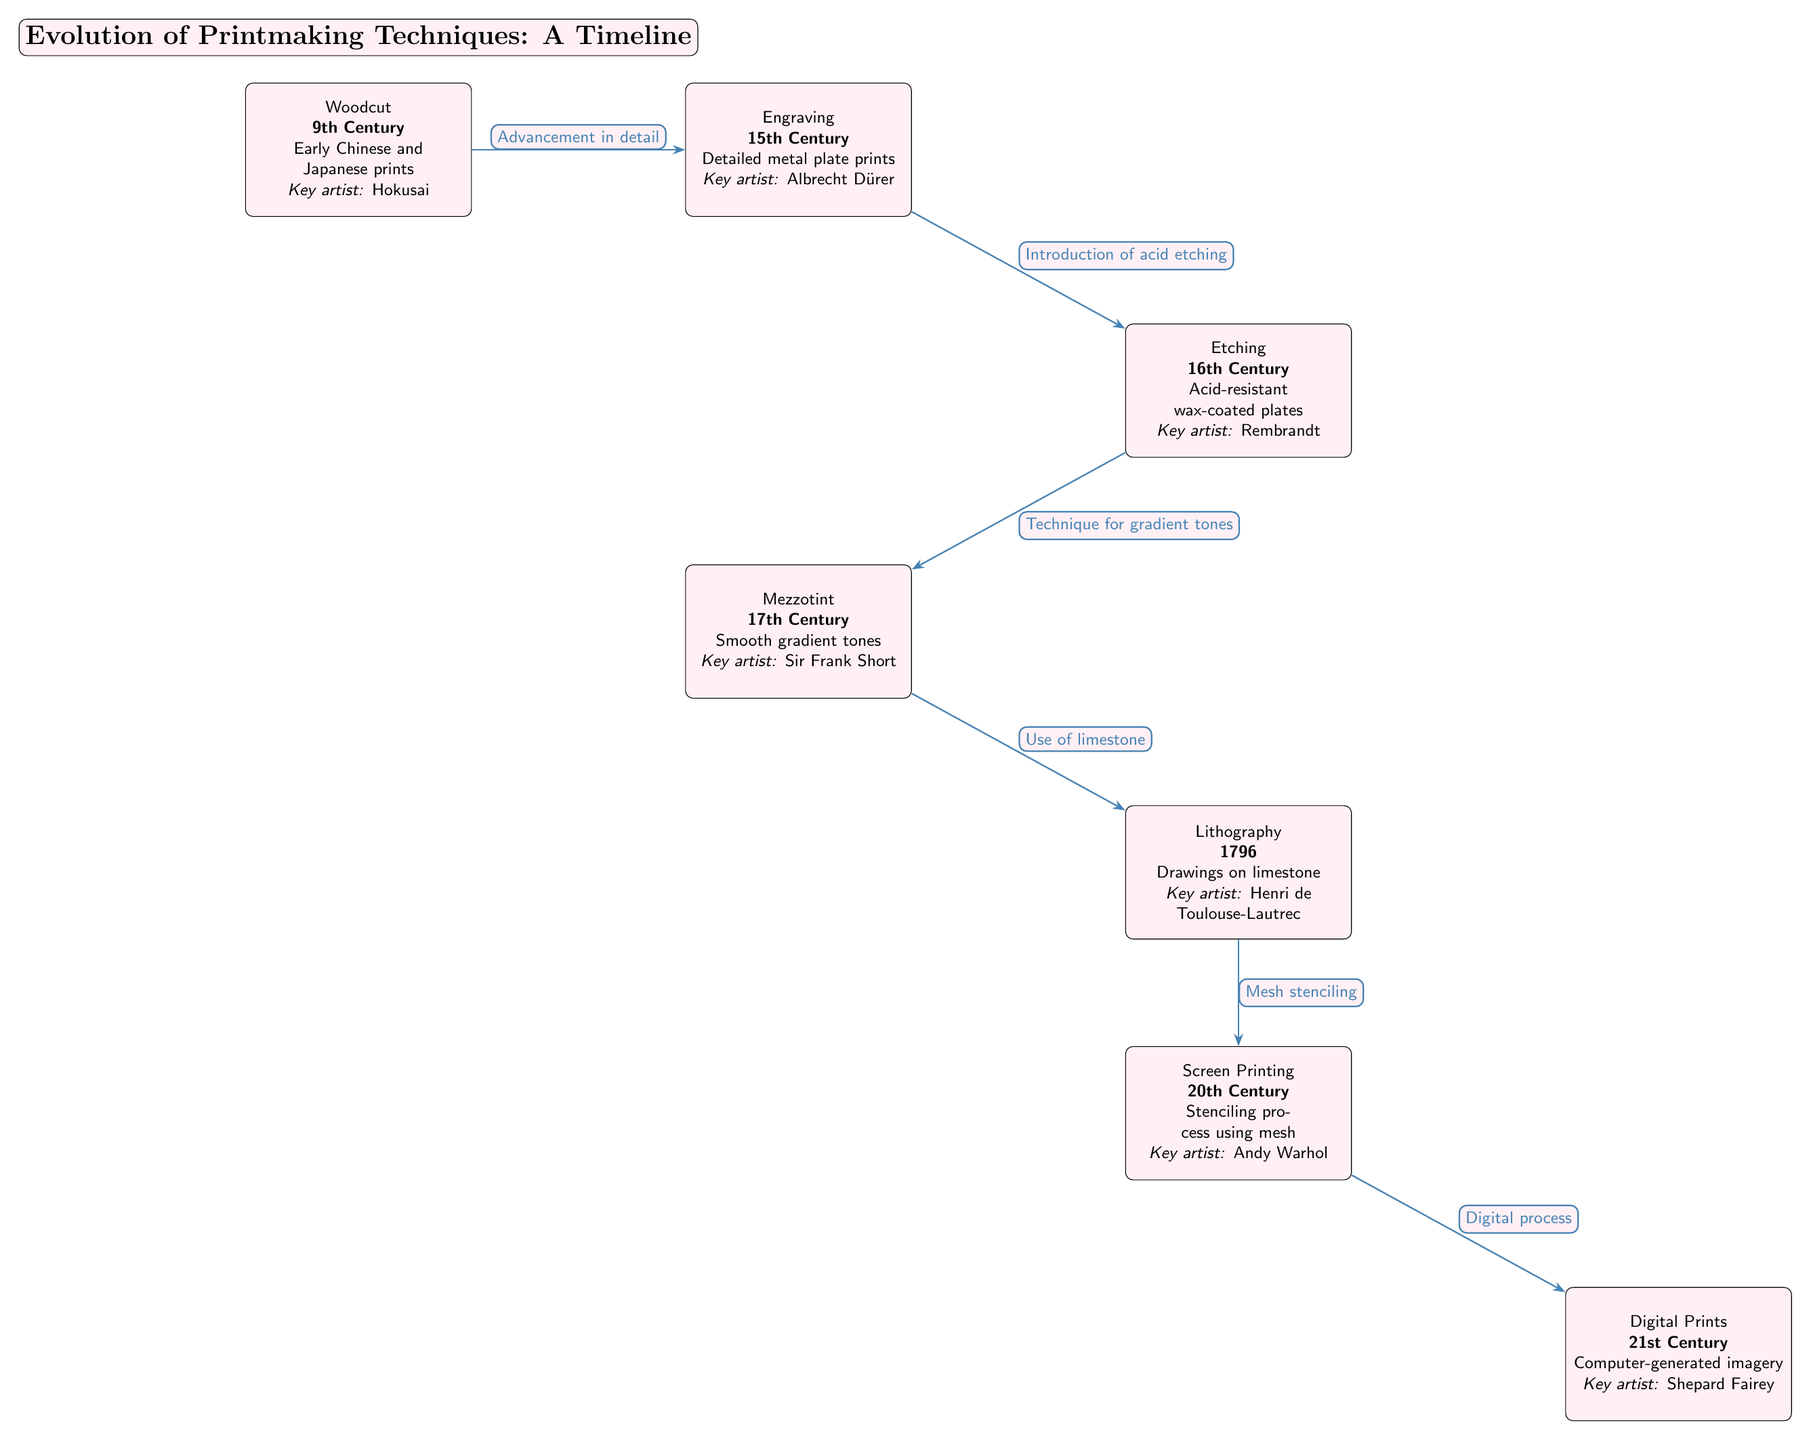What is the first technique in the timeline? The diagram lists "Woodcut" as the first technique, appearing at the top of the timeline under the 9th Century.
Answer: Woodcut Who is the key artist associated with engraving? According to the diagram, Albrecht Dürer is mentioned as the key artist associated with the engraving technique.
Answer: Albrecht Dürer What year did lithography emerge as a printmaking technique? The diagram specifies that lithography was introduced in the year 1796.
Answer: 1796 How many major printmaking techniques are shown in the diagram? Counting from Woodcut to Digital Prints, the diagram presents a total of six major printmaking techniques.
Answer: Six What advancement links engraving and etching? The diagram details that the transition from engraving to etching was marked by the "Introduction of acid etching."
Answer: Introduction of acid etching Which technique introduced the use of mesh stenciling? Per the diagram, screen printing is the technique that uses mesh stenciling, connecting to lithography through this method.
Answer: Screen Printing Name the technique that features "Smooth gradient tones." The diagram states that mezzotint is the technique noted for producing smooth gradient tones.
Answer: Mezzotint What is the last technique on the timeline? The last technique listed in the diagram is "Digital Prints," which appears at the bottom under the 21st Century.
Answer: Digital Prints What is the common characteristic of all the innovations shown? The diagram illustrates that each technique represents an advancement in printmaking methods leading from one technique to the next, culminating in the digital process.
Answer: Advancement in printmaking methods 